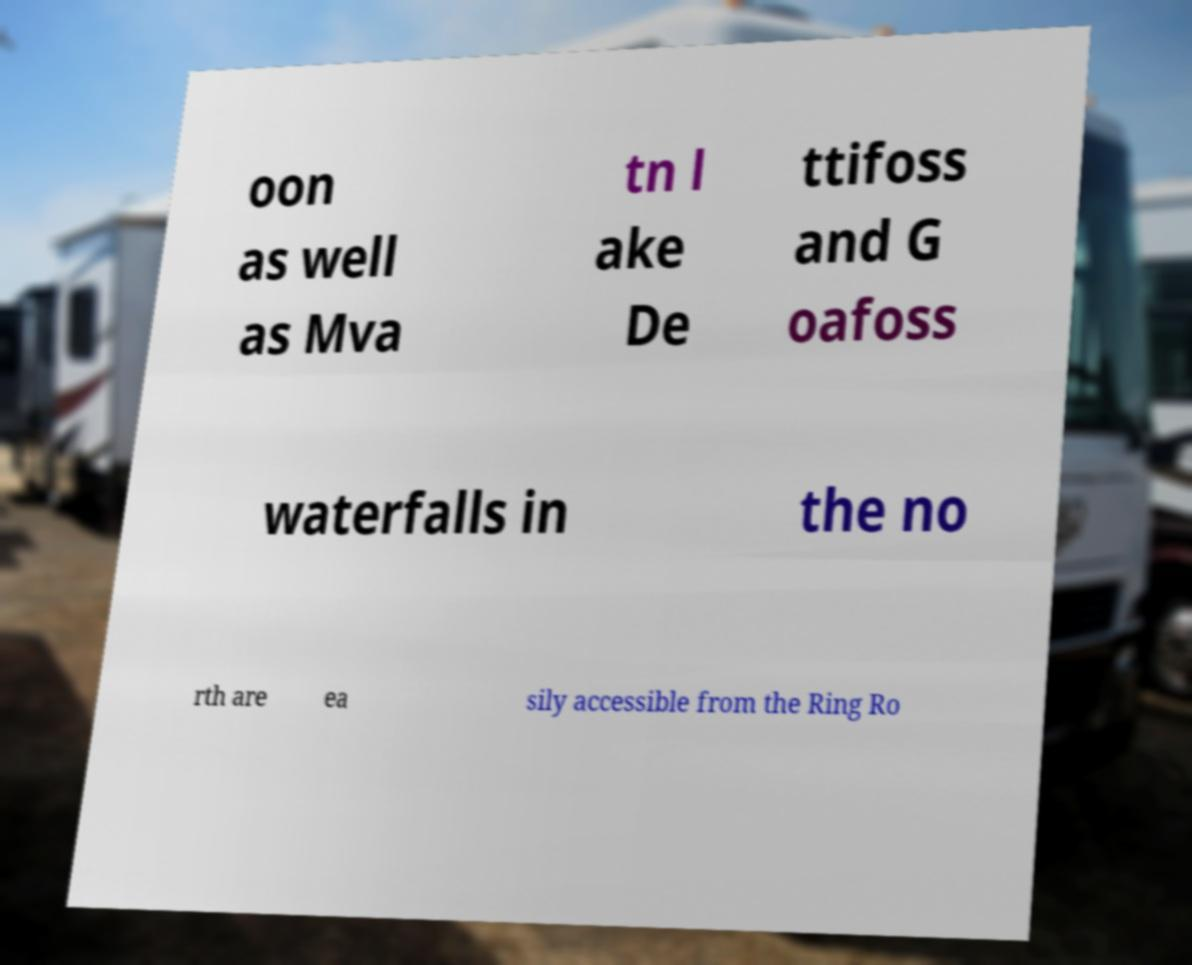Could you extract and type out the text from this image? oon as well as Mva tn l ake De ttifoss and G oafoss waterfalls in the no rth are ea sily accessible from the Ring Ro 